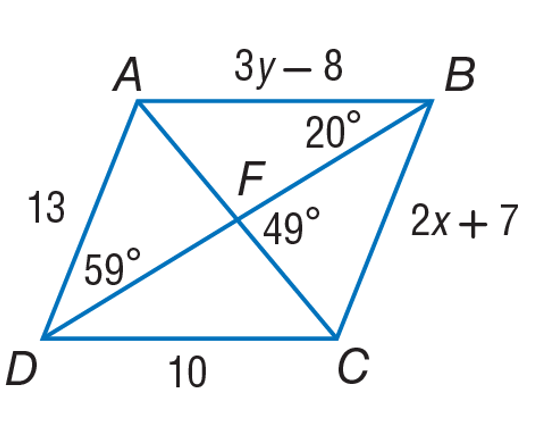Answer the mathemtical geometry problem and directly provide the correct option letter.
Question: Use parallelogram A B C D to find m \angle A F B.
Choices: A: 20 B: 49 C: 59 D: 131 D 